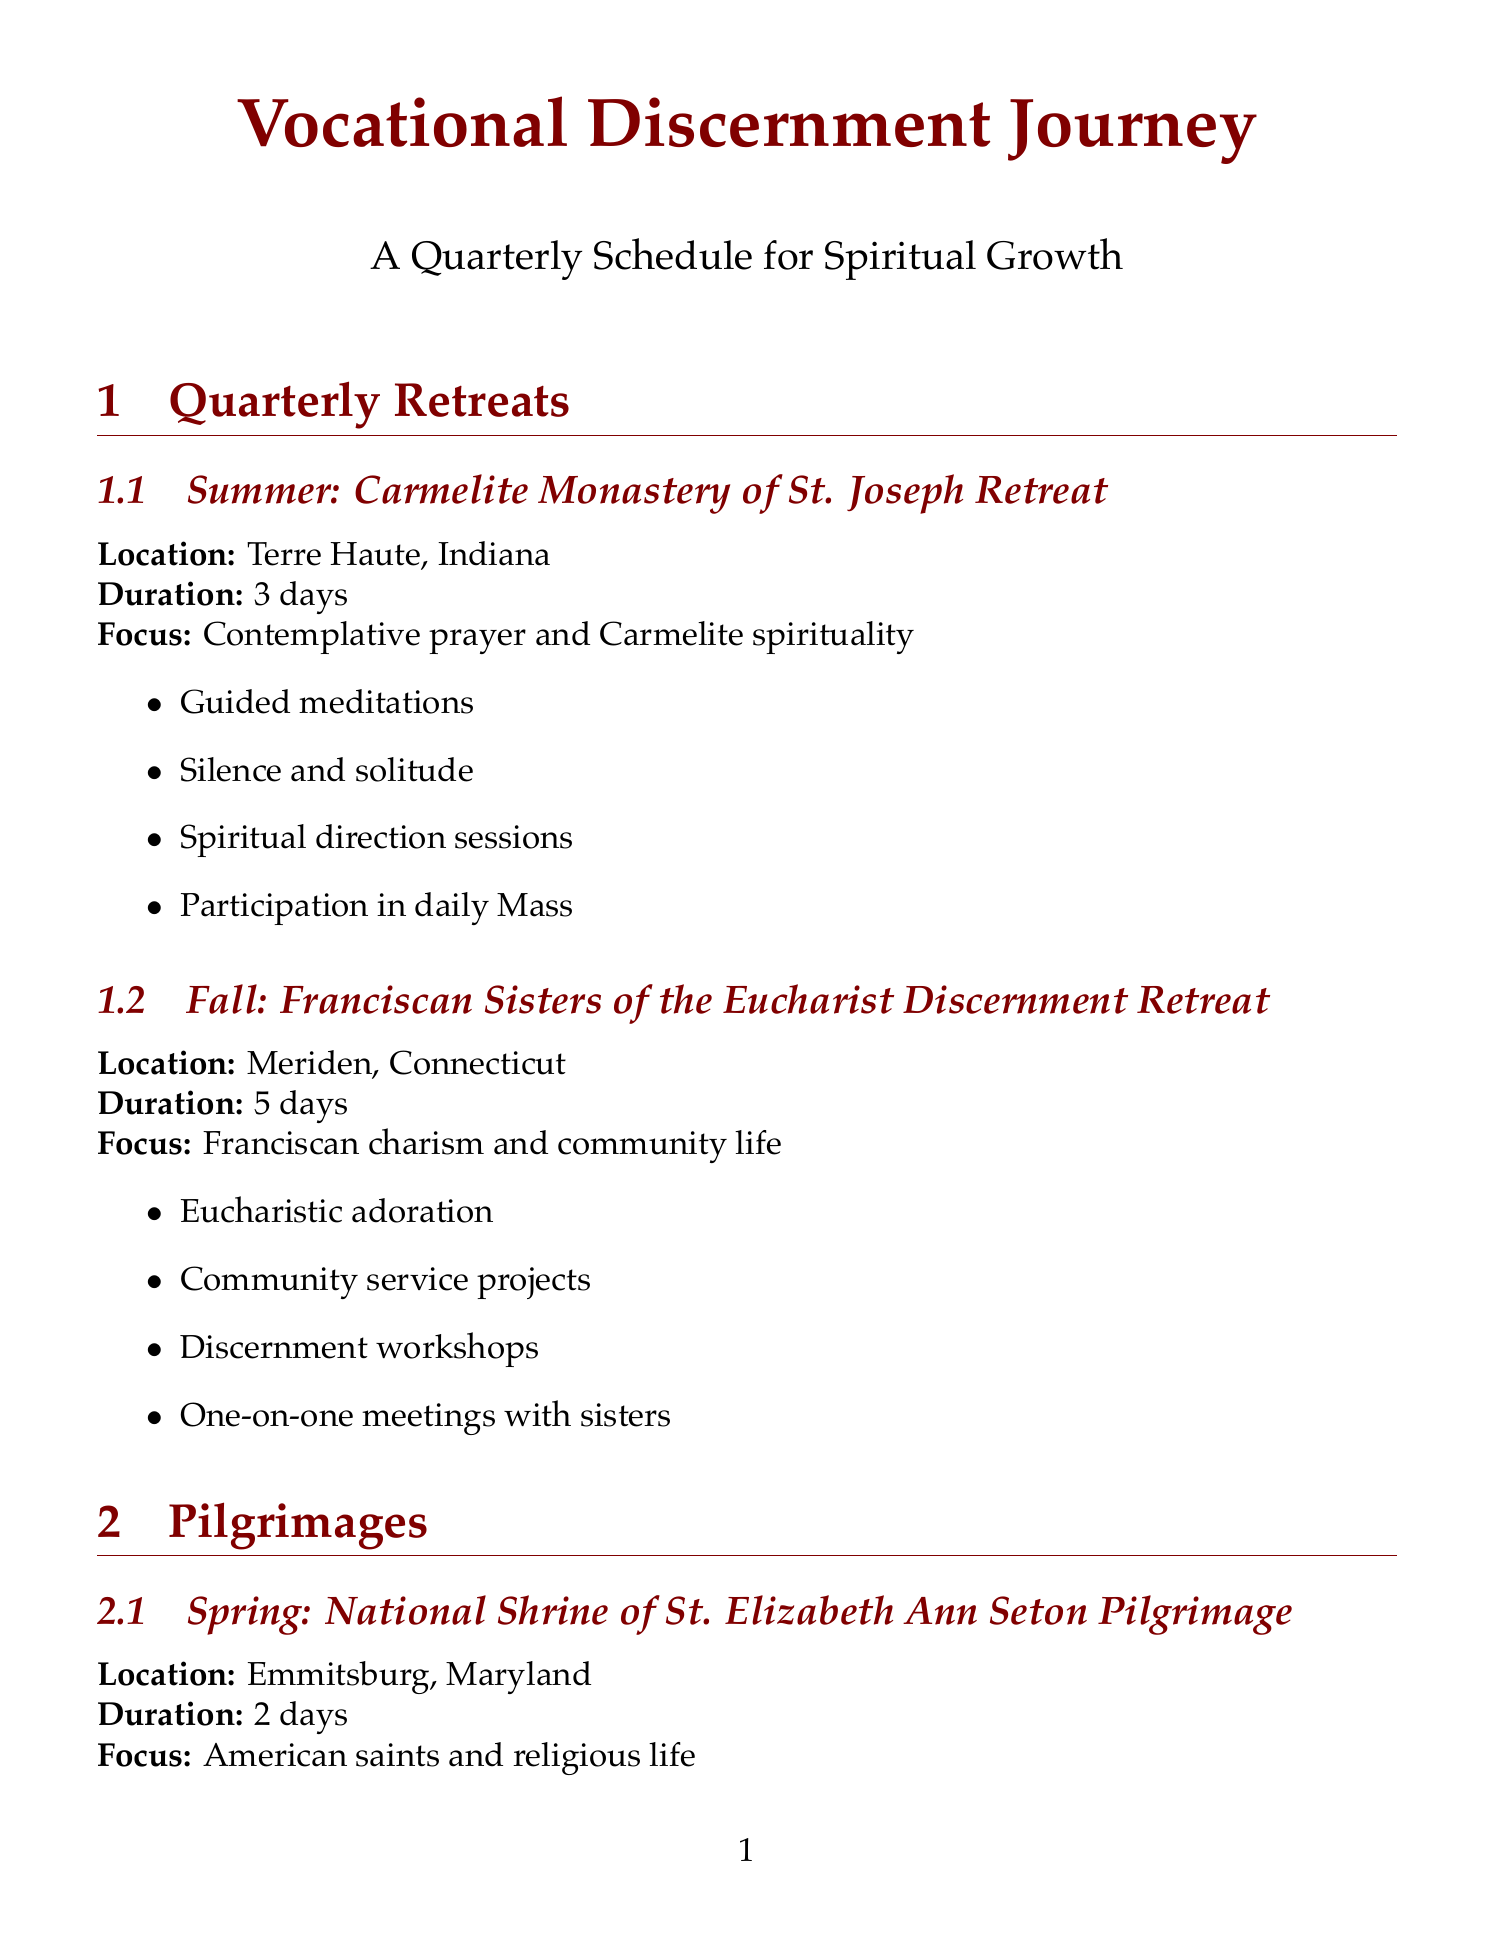What is the focus of the Carmelite Monastery of St. Joseph Retreat? The focus is outlined as "Contemplative prayer and Carmelite spirituality."
Answer: Contemplative prayer and Carmelite spirituality What is the duration of the Franciscan Sisters of the Eucharist Discernment Retreat? The duration of this retreat is specified as "5 days."
Answer: 5 days Where is the National Shrine of St. Elizabeth Ann Seton Pilgrimage located? The location is mentioned as "Emmitsburg, Maryland."
Answer: Emmitsburg, Maryland What activity is included in the Our Lady of Guadalupe Shrine Pilgrimage? One of the activities mentioned is "Rosary walk through the gardens."
Answer: Rosary walk through the gardens What type of resource is IgnatianSpirituality.com? The type is categorized as a "Website."
Answer: Website Which book by Fr. Walter J. Ciszek focuses on discerning God's will? The title mentioned is "He Leadeth Me."
Answer: He Leadeth Me How many days is the National Shrine of St. Elizabeth Ann Seton Pilgrimage? The duration is clearly stated as "2 days."
Answer: 2 days What is the focus of the ongoing resource Vocation Network? The focus is described as "Connecting with religious communities."
Answer: Connecting with religious communities 